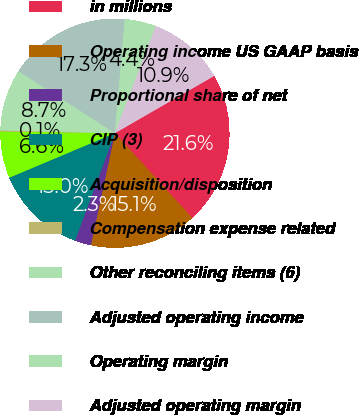Convert chart. <chart><loc_0><loc_0><loc_500><loc_500><pie_chart><fcel>in millions<fcel>Operating income US GAAP basis<fcel>Proportional share of net<fcel>CIP (3)<fcel>Acquisition/disposition<fcel>Compensation expense related<fcel>Other reconciling items (6)<fcel>Adjusted operating income<fcel>Operating margin<fcel>Adjusted operating margin<nl><fcel>21.56%<fcel>15.14%<fcel>2.29%<fcel>13.0%<fcel>6.58%<fcel>0.15%<fcel>8.72%<fcel>17.28%<fcel>4.43%<fcel>10.86%<nl></chart> 